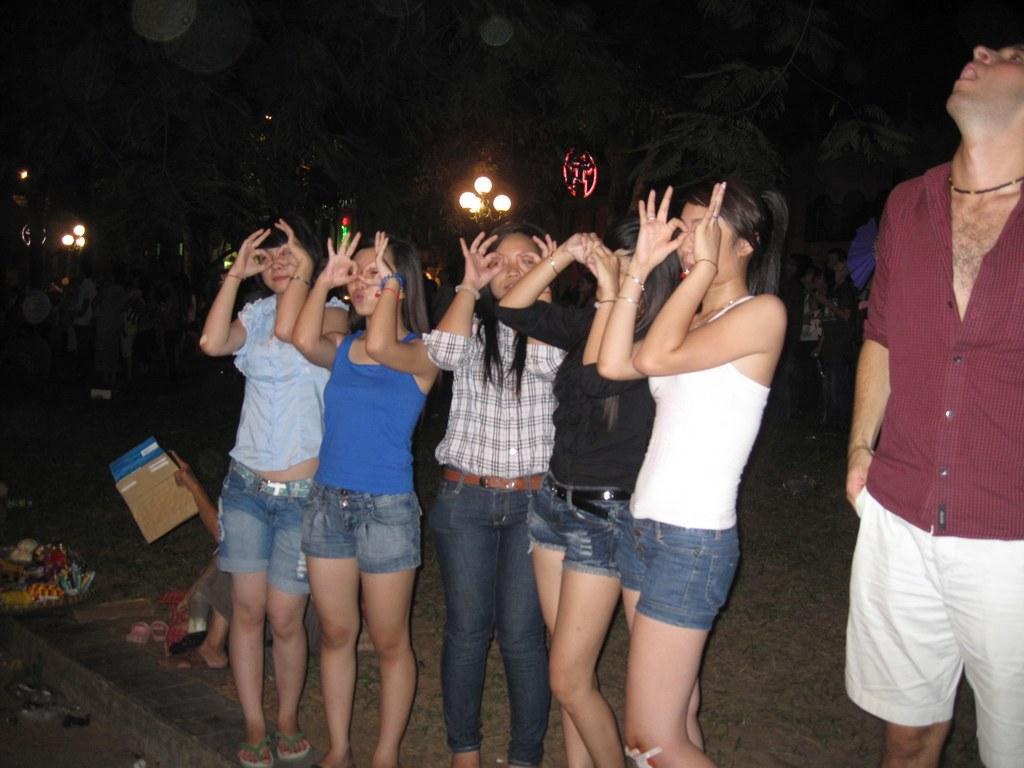Please provide a concise description of this image. In this image there is personś standing, there is a person holding an object, there are trees, there are lightś, there are objectś on the ground. 